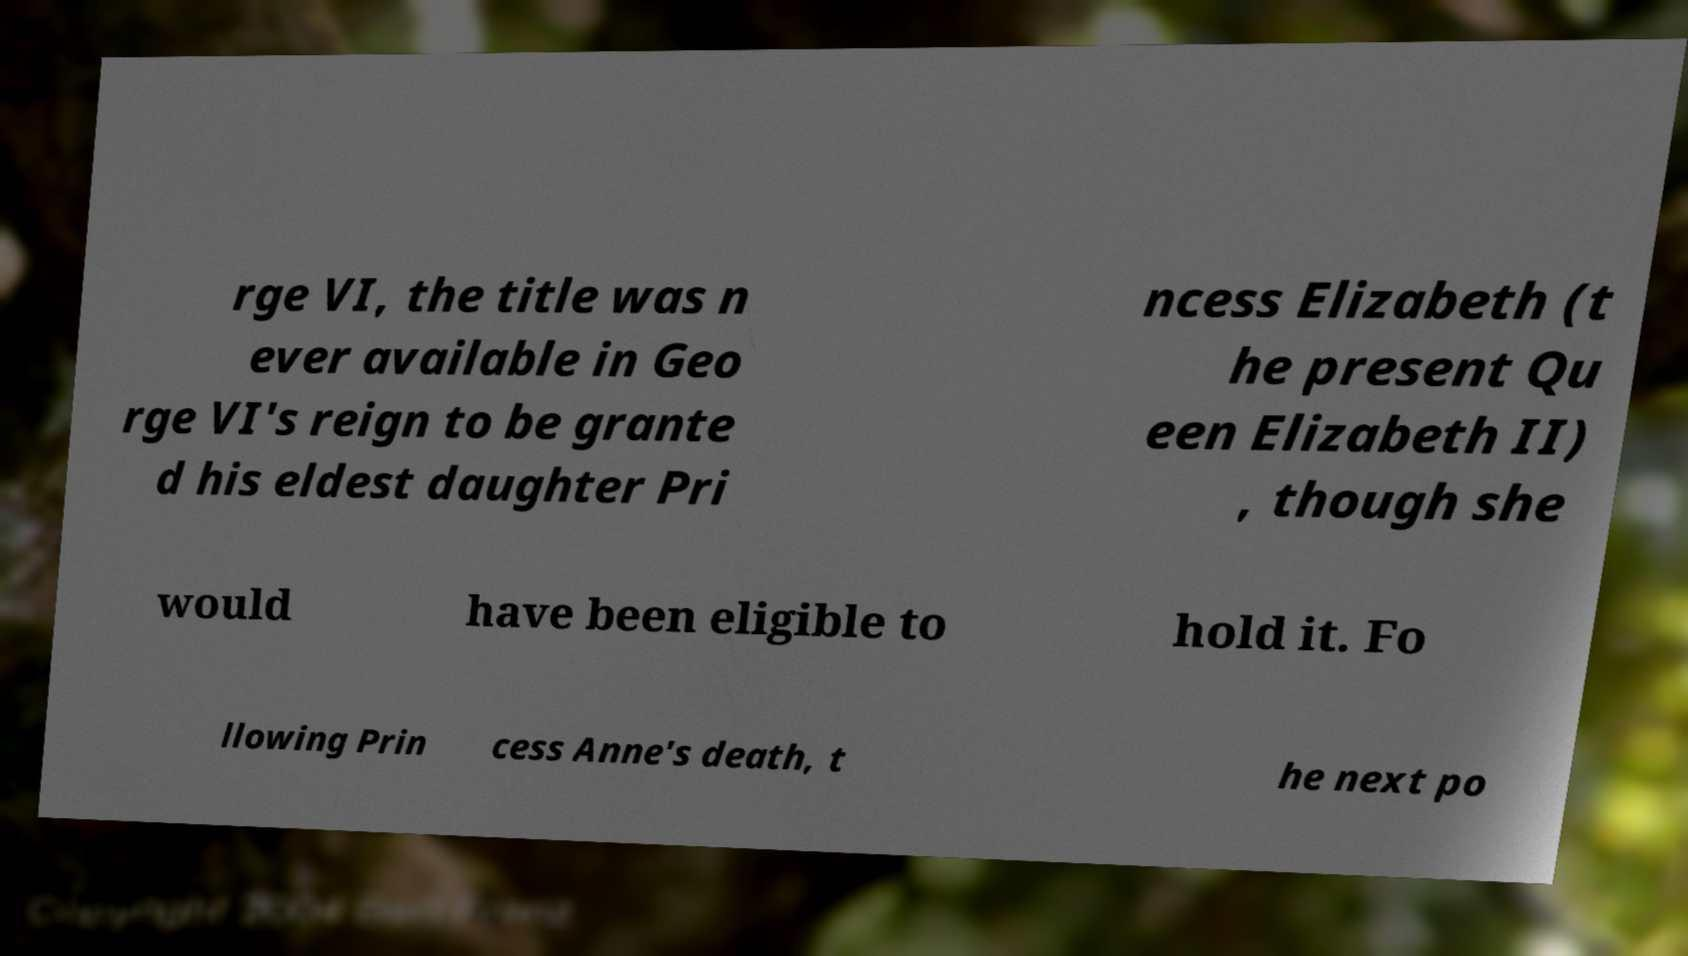Please read and relay the text visible in this image. What does it say? rge VI, the title was n ever available in Geo rge VI's reign to be grante d his eldest daughter Pri ncess Elizabeth (t he present Qu een Elizabeth II) , though she would have been eligible to hold it. Fo llowing Prin cess Anne's death, t he next po 